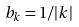Convert formula to latex. <formula><loc_0><loc_0><loc_500><loc_500>b _ { k } = 1 / | k |</formula> 